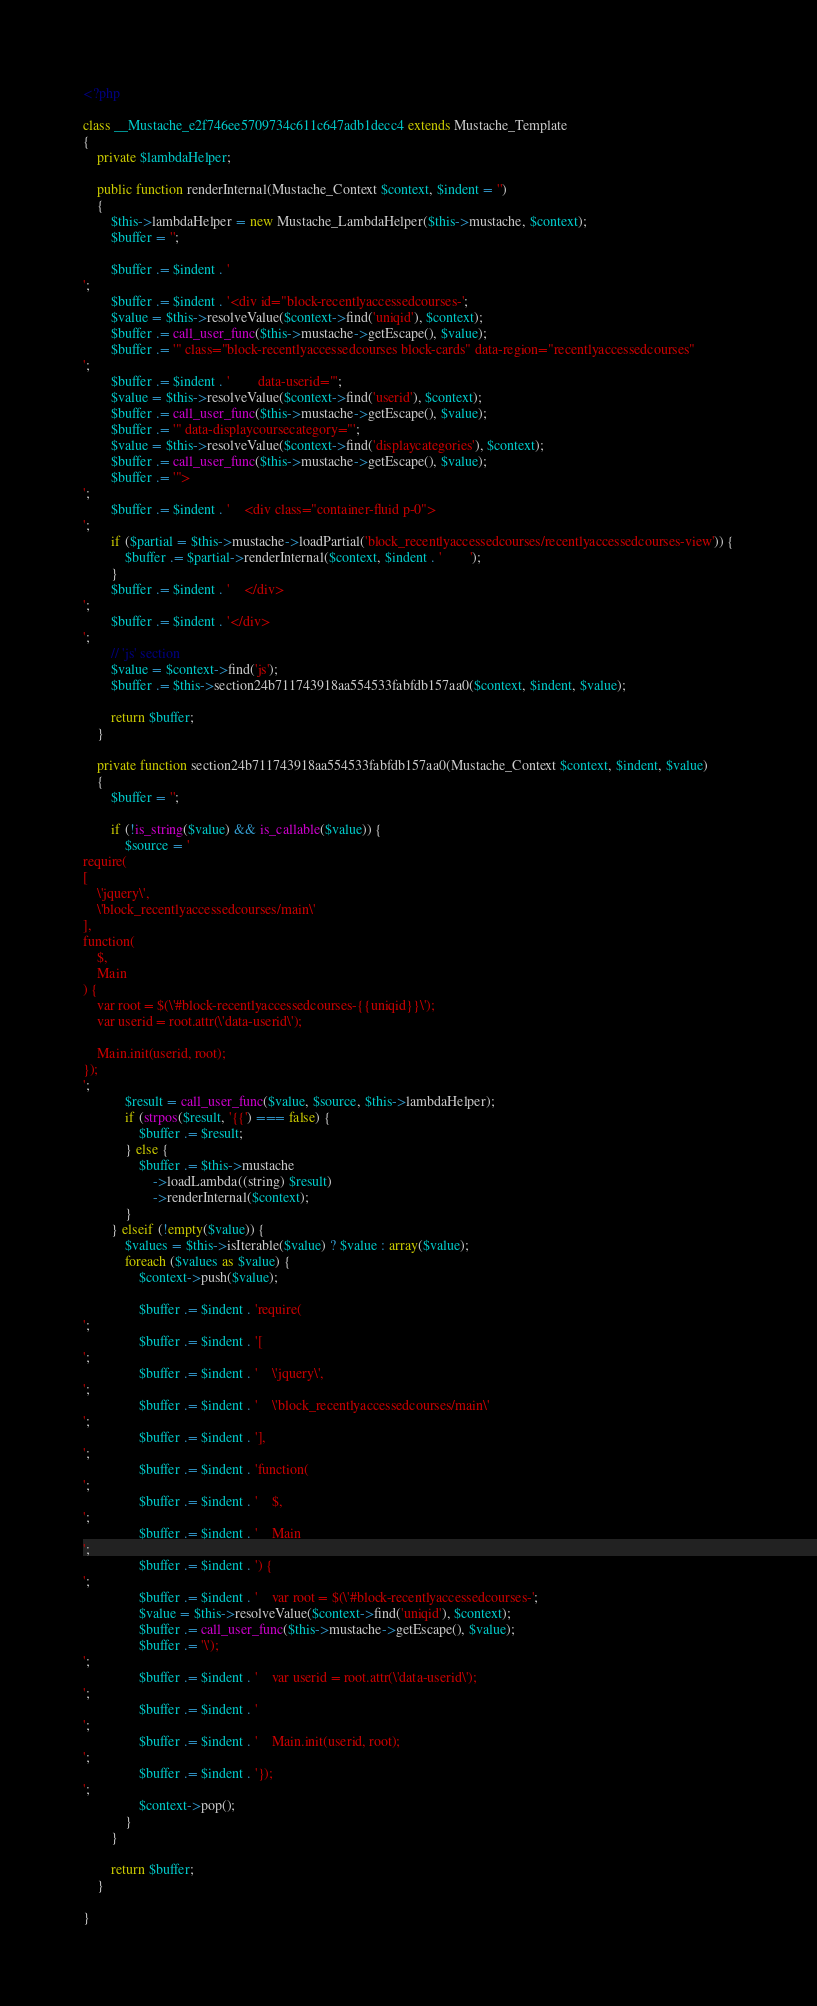Convert code to text. <code><loc_0><loc_0><loc_500><loc_500><_PHP_><?php

class __Mustache_e2f746ee5709734c611c647adb1decc4 extends Mustache_Template
{
    private $lambdaHelper;

    public function renderInternal(Mustache_Context $context, $indent = '')
    {
        $this->lambdaHelper = new Mustache_LambdaHelper($this->mustache, $context);
        $buffer = '';

        $buffer .= $indent . '
';
        $buffer .= $indent . '<div id="block-recentlyaccessedcourses-';
        $value = $this->resolveValue($context->find('uniqid'), $context);
        $buffer .= call_user_func($this->mustache->getEscape(), $value);
        $buffer .= '" class="block-recentlyaccessedcourses block-cards" data-region="recentlyaccessedcourses"
';
        $buffer .= $indent . '        data-userid="';
        $value = $this->resolveValue($context->find('userid'), $context);
        $buffer .= call_user_func($this->mustache->getEscape(), $value);
        $buffer .= '" data-displaycoursecategory="';
        $value = $this->resolveValue($context->find('displaycategories'), $context);
        $buffer .= call_user_func($this->mustache->getEscape(), $value);
        $buffer .= '">
';
        $buffer .= $indent . '    <div class="container-fluid p-0">
';
        if ($partial = $this->mustache->loadPartial('block_recentlyaccessedcourses/recentlyaccessedcourses-view')) {
            $buffer .= $partial->renderInternal($context, $indent . '        ');
        }
        $buffer .= $indent . '    </div>
';
        $buffer .= $indent . '</div>
';
        // 'js' section
        $value = $context->find('js');
        $buffer .= $this->section24b711743918aa554533fabfdb157aa0($context, $indent, $value);

        return $buffer;
    }

    private function section24b711743918aa554533fabfdb157aa0(Mustache_Context $context, $indent, $value)
    {
        $buffer = '';
    
        if (!is_string($value) && is_callable($value)) {
            $source = '
require(
[
    \'jquery\',
    \'block_recentlyaccessedcourses/main\'
],
function(
    $,
    Main
) {
    var root = $(\'#block-recentlyaccessedcourses-{{uniqid}}\');
    var userid = root.attr(\'data-userid\');

    Main.init(userid, root);
});
';
            $result = call_user_func($value, $source, $this->lambdaHelper);
            if (strpos($result, '{{') === false) {
                $buffer .= $result;
            } else {
                $buffer .= $this->mustache
                    ->loadLambda((string) $result)
                    ->renderInternal($context);
            }
        } elseif (!empty($value)) {
            $values = $this->isIterable($value) ? $value : array($value);
            foreach ($values as $value) {
                $context->push($value);
                
                $buffer .= $indent . 'require(
';
                $buffer .= $indent . '[
';
                $buffer .= $indent . '    \'jquery\',
';
                $buffer .= $indent . '    \'block_recentlyaccessedcourses/main\'
';
                $buffer .= $indent . '],
';
                $buffer .= $indent . 'function(
';
                $buffer .= $indent . '    $,
';
                $buffer .= $indent . '    Main
';
                $buffer .= $indent . ') {
';
                $buffer .= $indent . '    var root = $(\'#block-recentlyaccessedcourses-';
                $value = $this->resolveValue($context->find('uniqid'), $context);
                $buffer .= call_user_func($this->mustache->getEscape(), $value);
                $buffer .= '\');
';
                $buffer .= $indent . '    var userid = root.attr(\'data-userid\');
';
                $buffer .= $indent . '
';
                $buffer .= $indent . '    Main.init(userid, root);
';
                $buffer .= $indent . '});
';
                $context->pop();
            }
        }
    
        return $buffer;
    }

}
</code> 